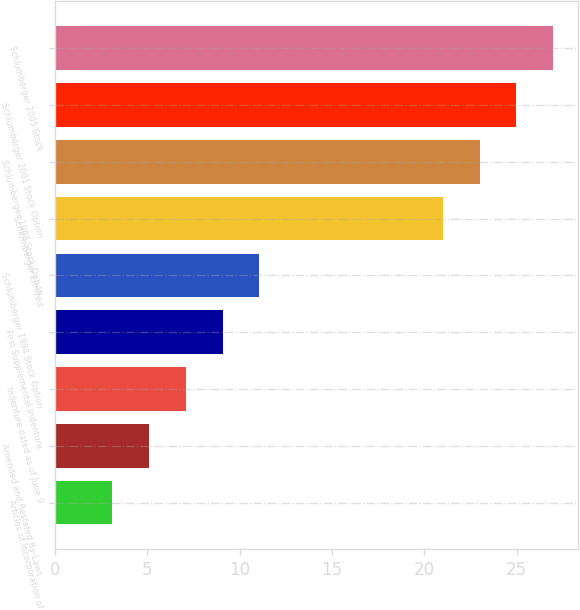Convert chart. <chart><loc_0><loc_0><loc_500><loc_500><bar_chart><fcel>Articles of Incorporation of<fcel>Amended and Restated By-Laws<fcel>Indenture dated as of June 9<fcel>First Supplemental Indenture<fcel>Schlumberger 1994 Stock Option<fcel>Schlumberger Limited<fcel>Schlumberger 1998 Stock Option<fcel>Schlumberger 2001 Stock Option<fcel>Schlumberger 2005 Stock<nl><fcel>3.1<fcel>5.09<fcel>7.08<fcel>9.07<fcel>11.06<fcel>21.01<fcel>23<fcel>24.99<fcel>26.98<nl></chart> 